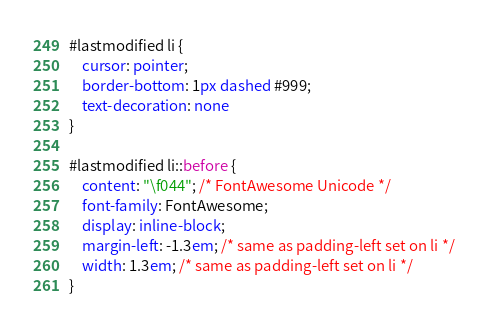Convert code to text. <code><loc_0><loc_0><loc_500><loc_500><_CSS_>#lastmodified li {
	cursor: pointer;
	border-bottom: 1px dashed #999;
	text-decoration: none
}

#lastmodified li::before {
	content: "\f044"; /* FontAwesome Unicode */
	font-family: FontAwesome;
	display: inline-block;
	margin-left: -1.3em; /* same as padding-left set on li */
	width: 1.3em; /* same as padding-left set on li */
}
</code> 